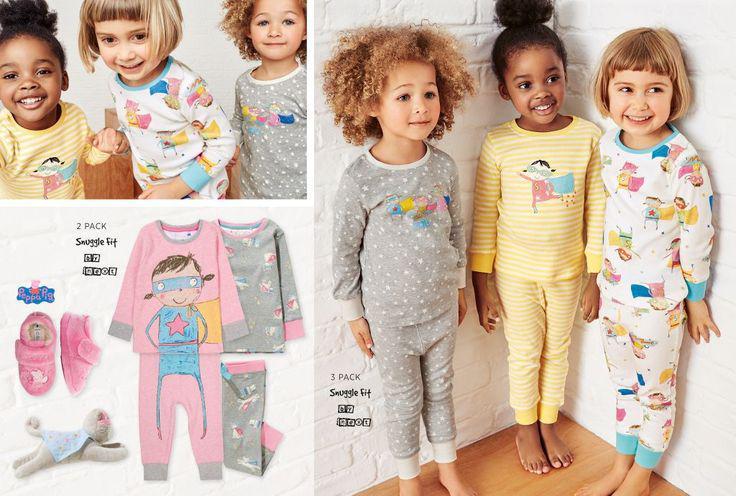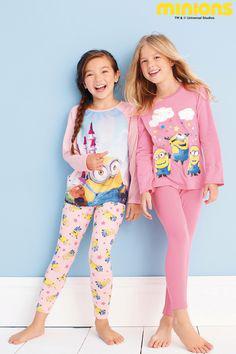The first image is the image on the left, the second image is the image on the right. Considering the images on both sides, is "Clothing is being modeled by children in each of the images." valid? Answer yes or no. Yes. The first image is the image on the left, the second image is the image on the right. For the images shown, is this caption "Some outfits feature a pink cartoon pig, and each image contains exactly two sleepwear outfits." true? Answer yes or no. No. 